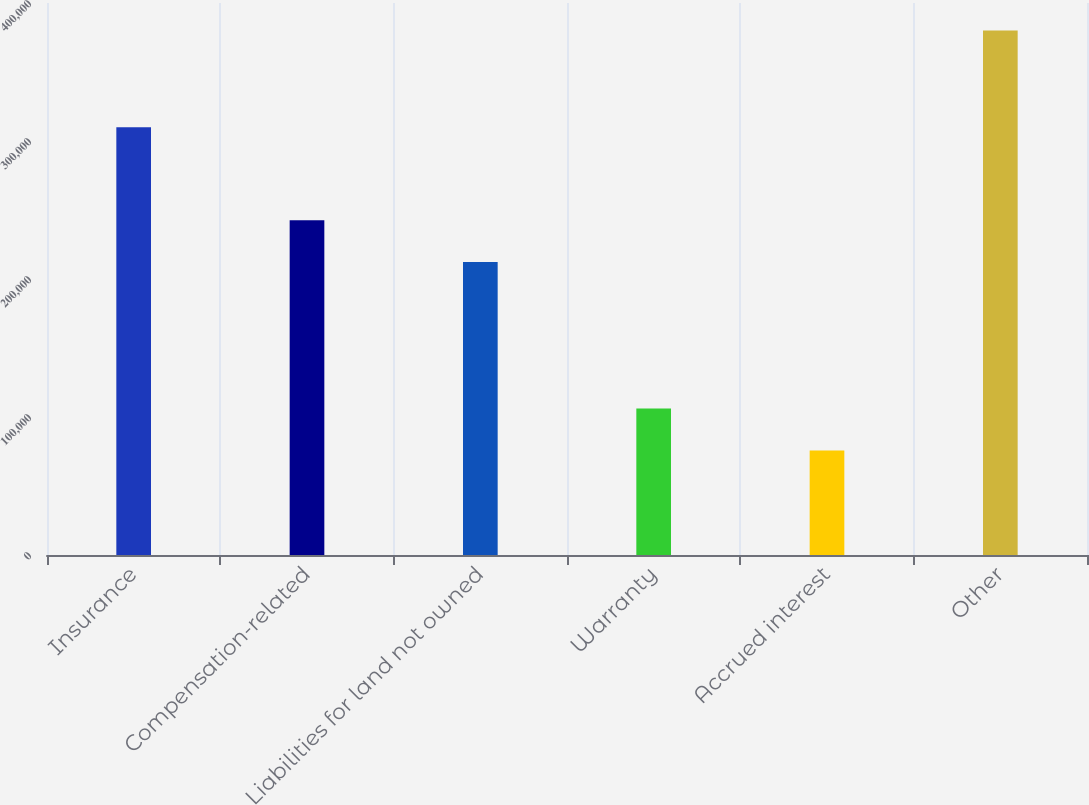Convert chart to OTSL. <chart><loc_0><loc_0><loc_500><loc_500><bar_chart><fcel>Insurance<fcel>Compensation-related<fcel>Liabilities for land not owned<fcel>Warranty<fcel>Accrued interest<fcel>Other<nl><fcel>309874<fcel>242656<fcel>212235<fcel>106203<fcel>75782<fcel>379990<nl></chart> 